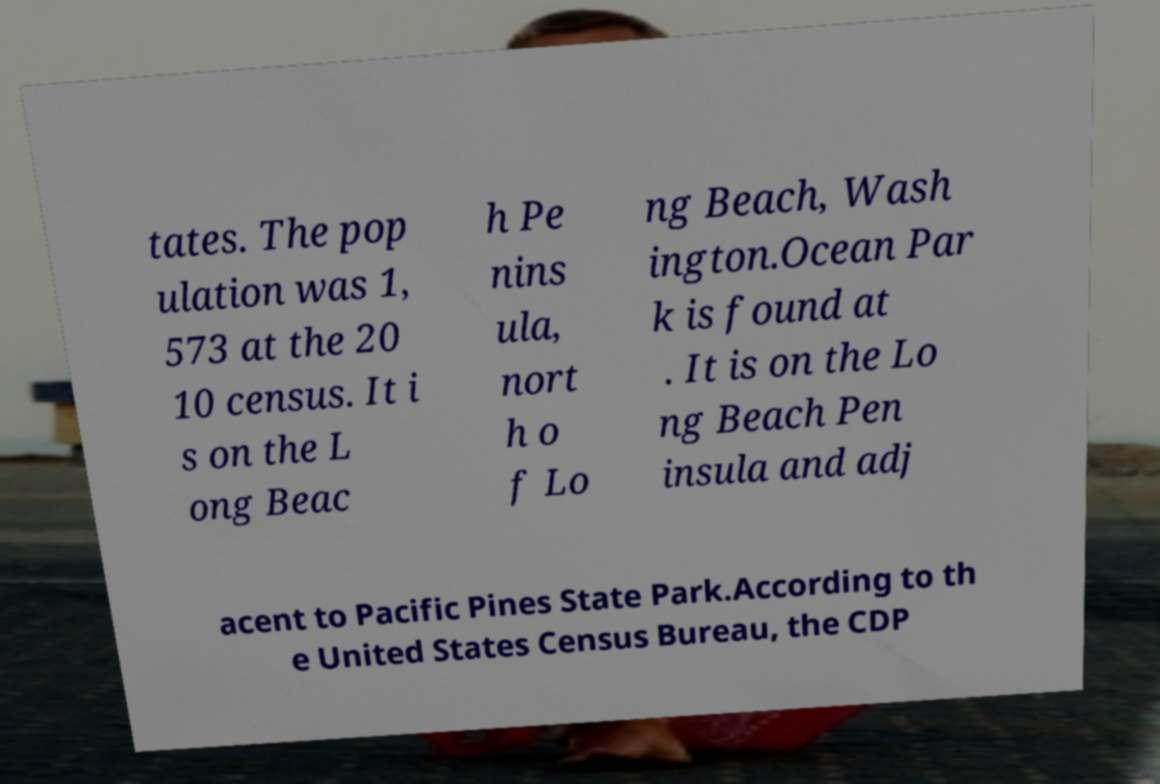What messages or text are displayed in this image? I need them in a readable, typed format. tates. The pop ulation was 1, 573 at the 20 10 census. It i s on the L ong Beac h Pe nins ula, nort h o f Lo ng Beach, Wash ington.Ocean Par k is found at . It is on the Lo ng Beach Pen insula and adj acent to Pacific Pines State Park.According to th e United States Census Bureau, the CDP 